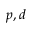<formula> <loc_0><loc_0><loc_500><loc_500>p , d</formula> 